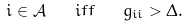<formula> <loc_0><loc_0><loc_500><loc_500>i \in \mathcal { A } \quad i f f \quad g _ { i i } > \Delta .</formula> 